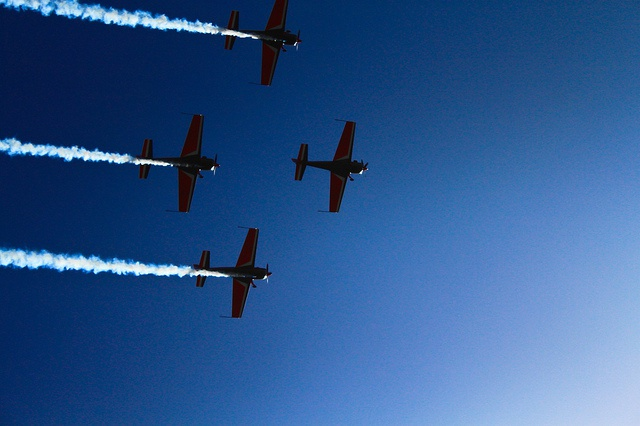Describe the objects in this image and their specific colors. I can see airplane in lightblue, black, navy, white, and gray tones, airplane in lightblue, black, navy, white, and gray tones, airplane in lightblue, black, blue, navy, and darkblue tones, and airplane in lightblue, black, blue, lightgray, and navy tones in this image. 